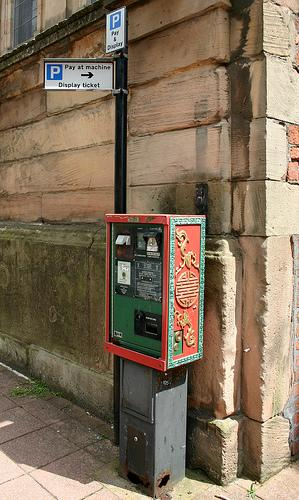Create a narrative based on the main elements in the picture. The parking ticket machine stands against a backdrop of weathered stone and brick, adorned with a vibrant red and gold Asian-inspired design. Above, a simple blue and white sign instructs visitors to "Pay at machine, Display ticket," capturing the mundane yet essential aspect of urban life. Describe a scene in the image as if it were a photograph featured in a gallery. This photograph captures a slice of urban functionality with artistic flair. A parking ticket machine, featuring a striking red and gold design, contrasts with the muted tones of the weathered brick wall behind it. The practical blue and white parking sign adds a layer of everyday utility to the scene. Mention the objects found in the image focusing on their colors. Red and gold parking ticket machine, weathered brick wall in shades of beige and brown, and a blue and white parking sign. Describe the scene in the image in a poetic manner. Against the canvas of time-worn bricks, a machine clad in red and gold stands as a sentinel of modernity, its vibrant colors a stark contrast to the muted earth tones that surround it, all under the watchful eye of a directive blue and white sign. List the items in the image that stand out the most. The red and gold parking ticket machine, the weathered brick wall, and the blue and white parking sign. Describe the setting and atmosphere of the image. The scene is set against an aged brick wall, where a vividly decorated parking ticket machine and a straightforward parking sign blend the old with the new, reflecting a typical urban environment. Provide a succinct description of the various elements found in the photo. A weathered brick wall, a red and gold parking ticket machine, and a blue and white parking sign combine to depict a functional yet visually striking urban corner. Provide a brief overview of the main elements in the picture. The image features a red and gold parking ticket machine, a blue and white parking sign, and a backdrop of a weathered brick wall. Mention the smallest and largest objects in the image. The smallest object is the lock on the parking ticket machine, while the largest is the brick wall. Write a sentence including the main objects present in the image. Nestled against a backdrop of an aged brick wall, the red and gold parking ticket machine stands prominently beneath a blue and white sign instructing visitors on its use. 